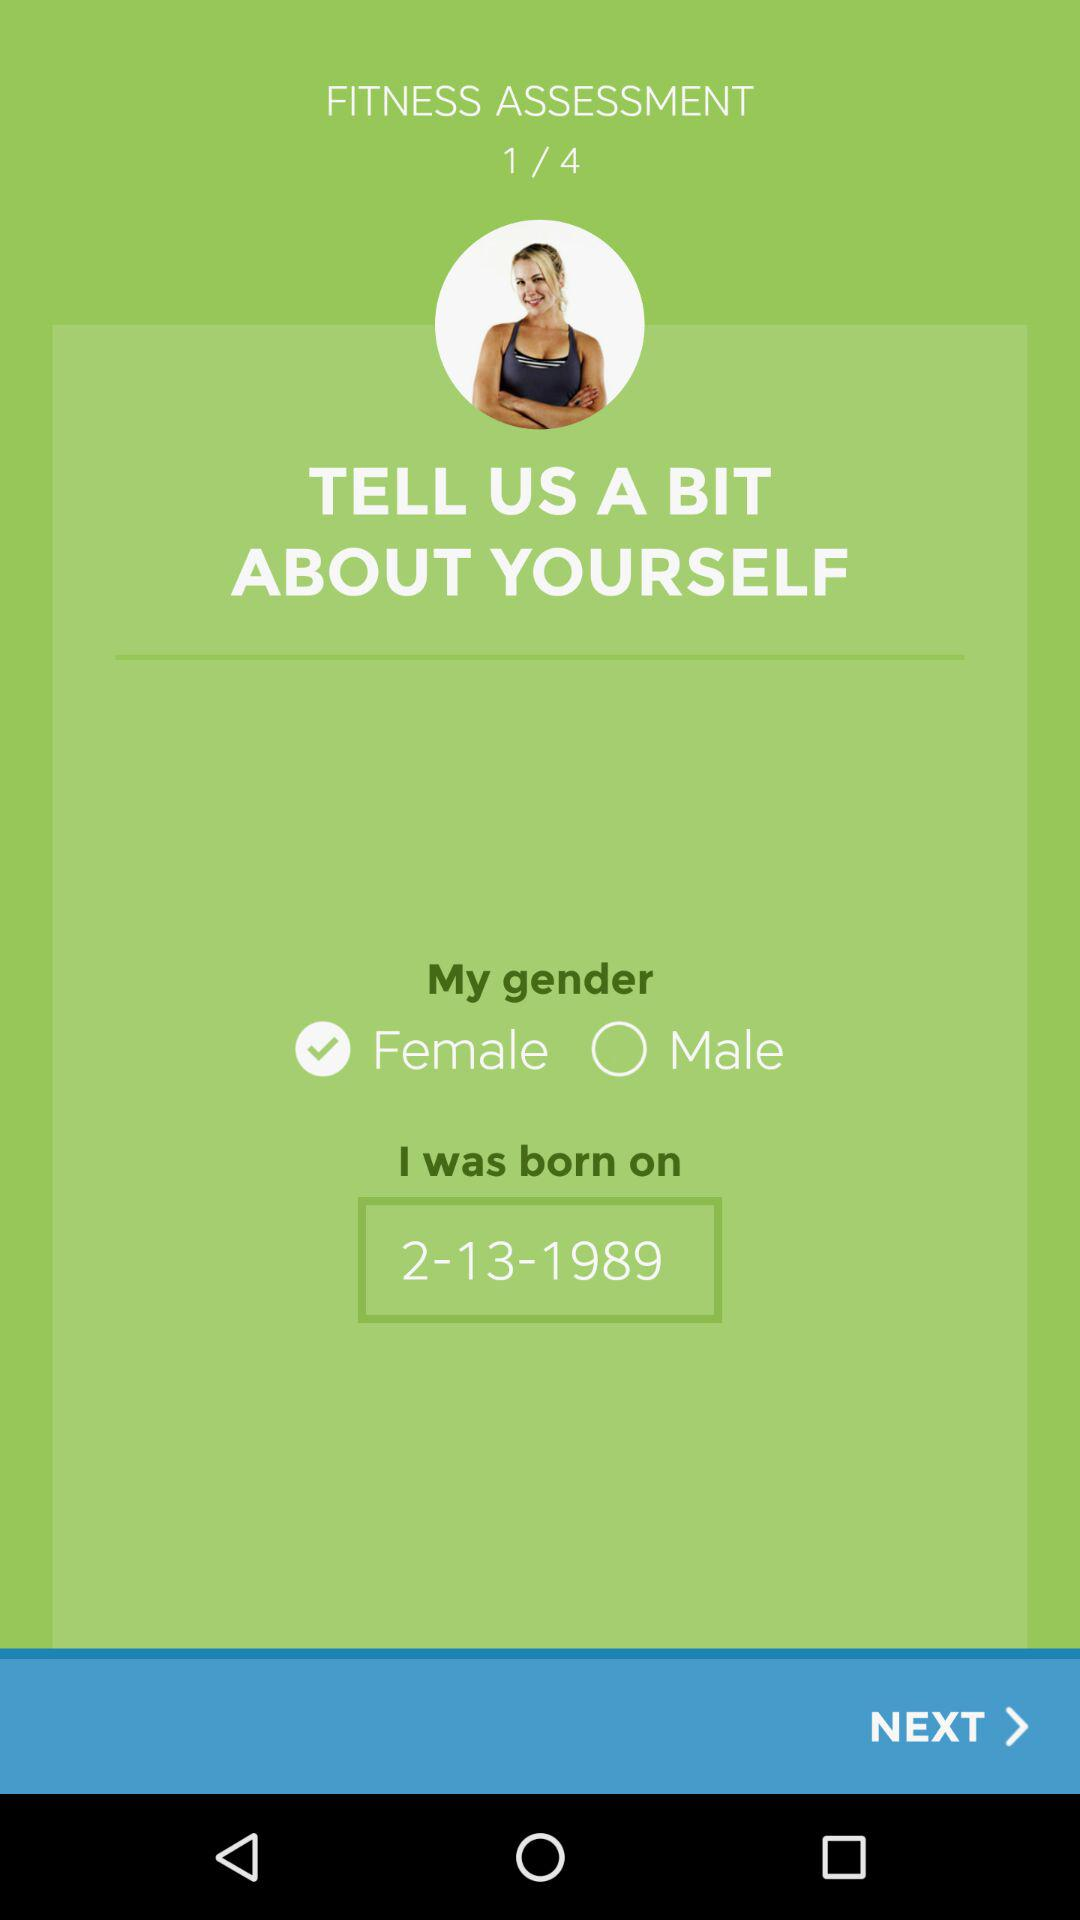What is the gender? The gender is female. 